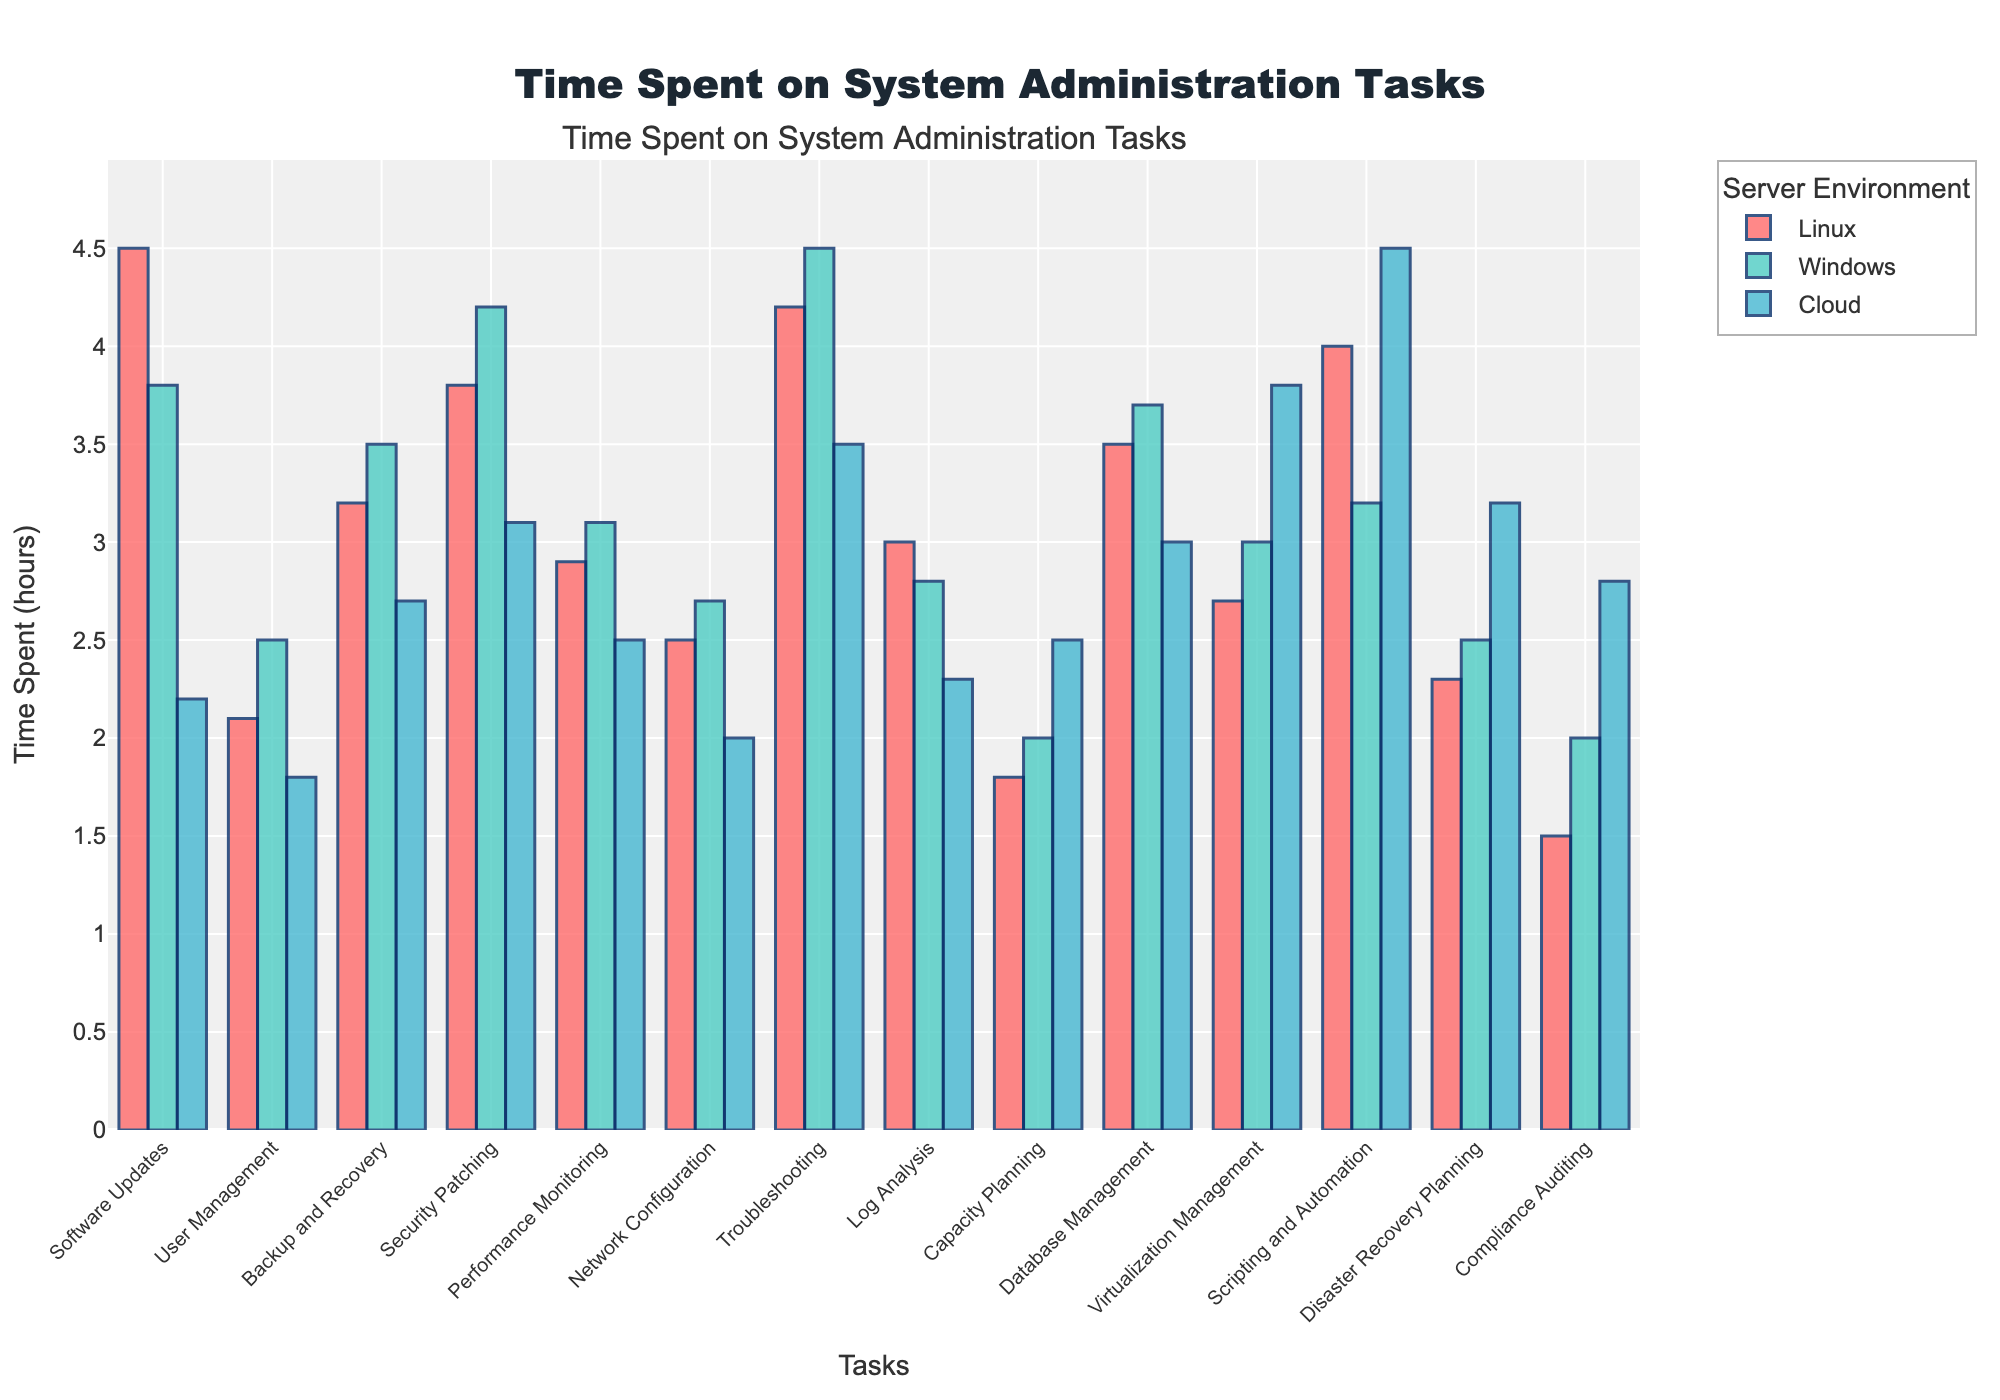Which task has the highest time spent for Linux? Look for the highest bar among the bars representing Linux. The highest bar corresponds to Scripting and Automation with a time of 4.0 hours.
Answer: Scripting and Automation How much more time is spent on Troubleshooting compared to Log Analysis for Windows? Find the bar heights for both Troubleshooting and Log Analysis in the Windows category. Troubleshooting has a height of 4.5 hours, and Log Analysis has 2.8 hours. The difference is 4.5 - 2.8 = 1.7 hours.
Answer: 1.7 hours What is the average time spent on Security Patching across all server environments? Sum up the times spent on Security Patching for Linux, Windows, and Cloud and divide by the number of categories: (3.8 + 4.2 + 3.1) / 3 = 11.1 / 3 = 3.7 hours.
Answer: 3.7 hours In which server environment is the time spent on Database Management the lowest? Compare the bar heights for Database Management across Linux, Windows, and Cloud. The bars represent 3.5, 3.7, and 3.0 hours respectively. The lowest is 3.0 hours under Cloud.
Answer: Cloud Which task shows the smallest difference in time spent between Linux and Cloud? Calculate the absolute differences in time spent across all tasks between Linux and Cloud and find the minimum. The differences are: 2.3, 0.3, 0.5, 0.7, 0.4, 0.5, 0.7, 0.7, -0.7, 0.5, -1.1, -0.5, -0.9, -1.3. The smallest difference is for Performance Monitoring with 0.4 hours.
Answer: Performance Monitoring For which task does Cloud have the highest time expenditure compared to both Linux and Windows? Evaluate the tasks where the Cloud's time is higher than both Linux and Windows. The only task where Cloud exceeds both is Scripting and Automation with 4.5 hours compared to 4.0 (Linux) and 3.2 (Windows).
Answer: Scripting and Automation What is the total time spent on Network Configuration across all server environments? Add the times spent on Network Configuration for Linux, Windows, and Cloud: 2.5 + 2.7 + 2.0 = 7.2 hours.
Answer: 7.2 hours Which task shows the largest discrepancy in time spent between the environments with the highest and lowest values? Determine the maximum and minimum time spent for each task among the environments. Identify the task with the greatest difference between these two values. Scripting and Automation shows the largest discrepancy with (4.5 - 3.2) = 1.3 hours.
Answer: Scripting and Automation 